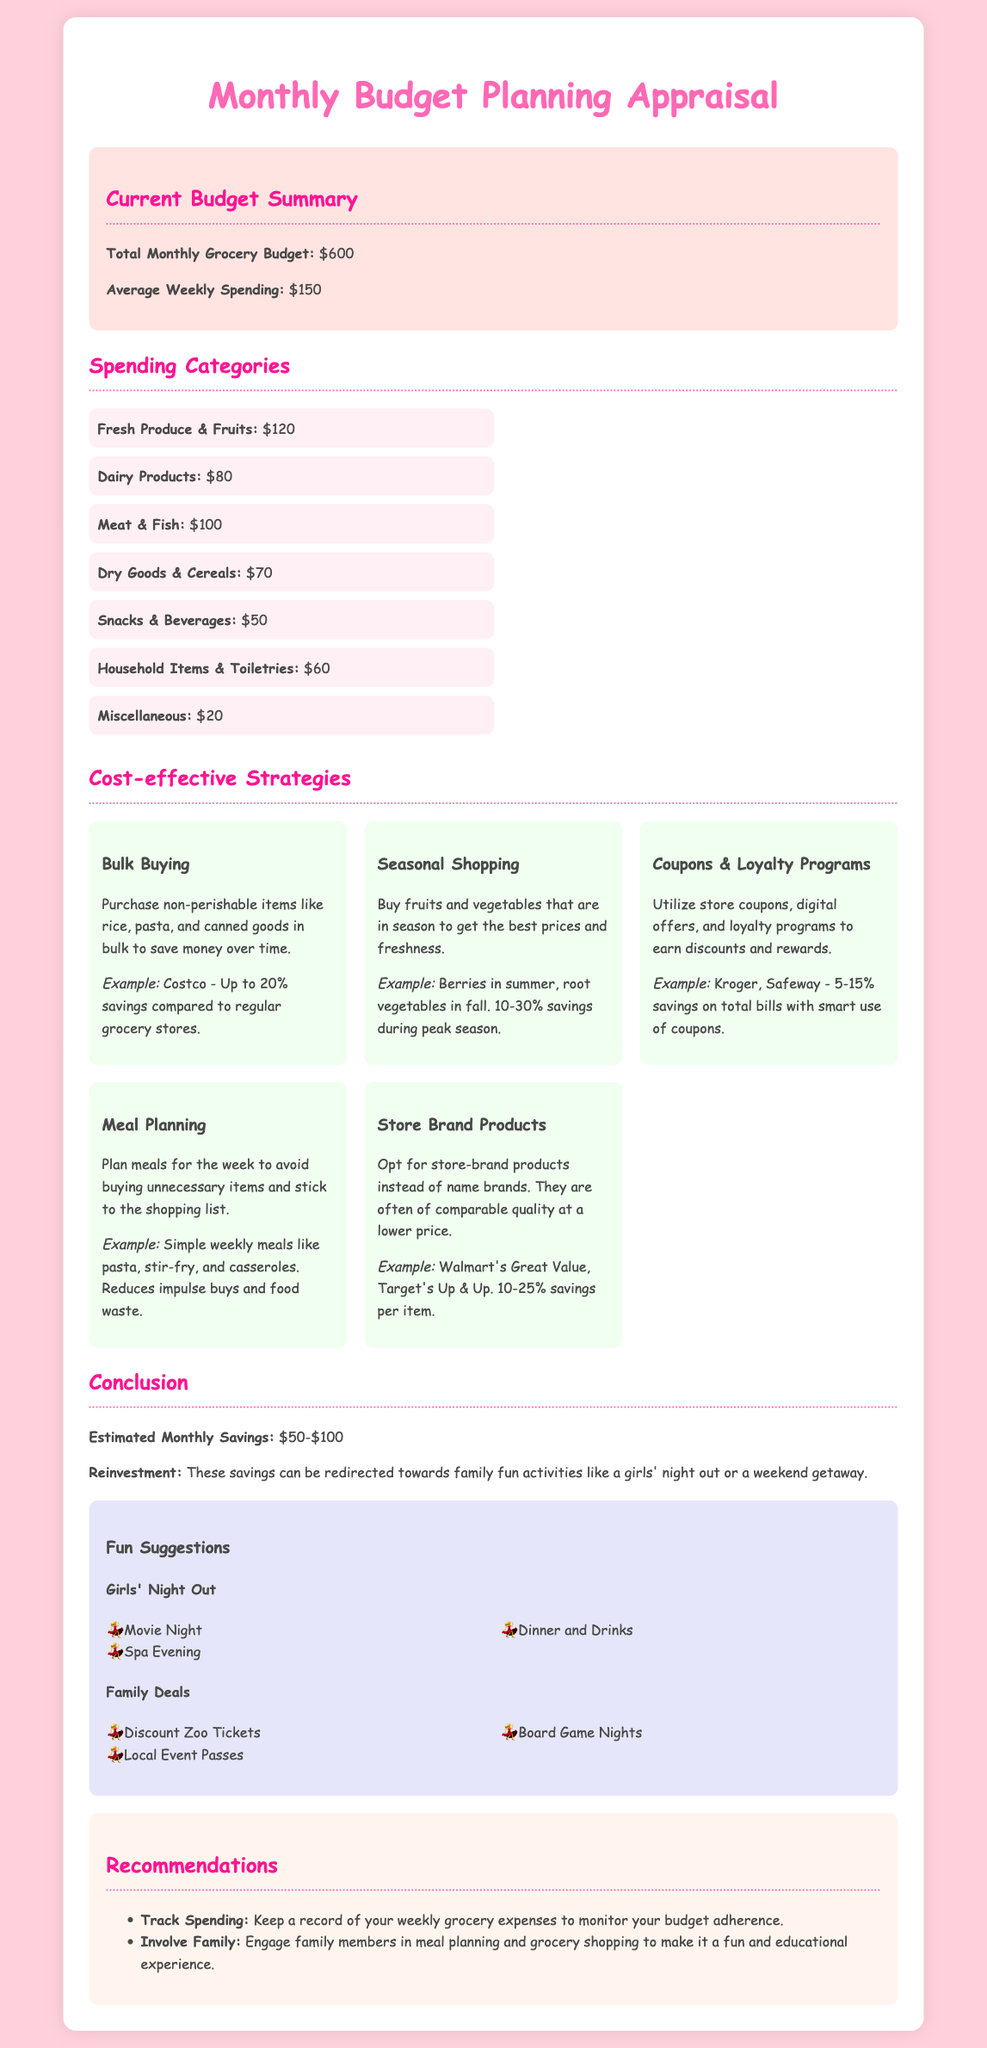What is the total monthly grocery budget? The total monthly grocery budget is stated in the document as $600.
Answer: $600 What are the average weekly spending figures? The average weekly spending provided in the document is $150 per week.
Answer: $150 How much is allocated for Fresh Produce & Fruits? The document specifies that Fresh Produce & Fruits have a budget of $120.
Answer: $120 What strategy is mentioned for saving money through purchasing? The strategy discussed for saving money involves Bulk Buying non-perishable items.
Answer: Bulk Buying What is the estimated monthly savings range? The estimated monthly savings outlined in the document is between $50 and $100.
Answer: $50-$100 Which store brand products are mentioned? The document mentions Walmart's Great Value and Target's Up & Up as examples of store brand products.
Answer: Walmart's Great Value, Target's Up & Up What does the document suggest about family involvement in budgeting? The document recommends involving family members in meal planning and grocery shopping for a fun experience.
Answer: Involve Family What fun suggestion is provided for a girls' night out? A fun suggestion for a girls' night out from the document is going to a Movie Night.
Answer: Movie Night How much is spent on Household Items & Toiletries? The spending on Household Items & Toiletries is detailed as $60 in the document.
Answer: $60 